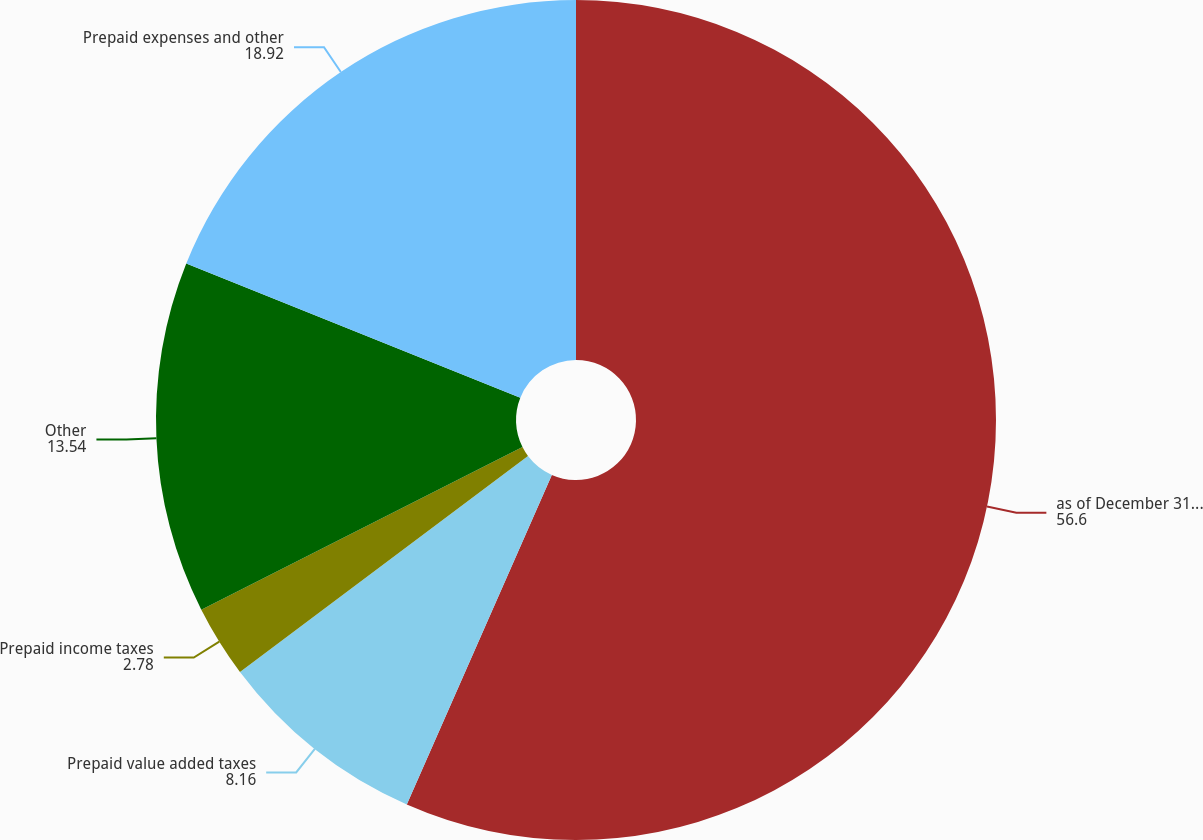Convert chart to OTSL. <chart><loc_0><loc_0><loc_500><loc_500><pie_chart><fcel>as of December 31 (in<fcel>Prepaid value added taxes<fcel>Prepaid income taxes<fcel>Other<fcel>Prepaid expenses and other<nl><fcel>56.6%<fcel>8.16%<fcel>2.78%<fcel>13.54%<fcel>18.92%<nl></chart> 